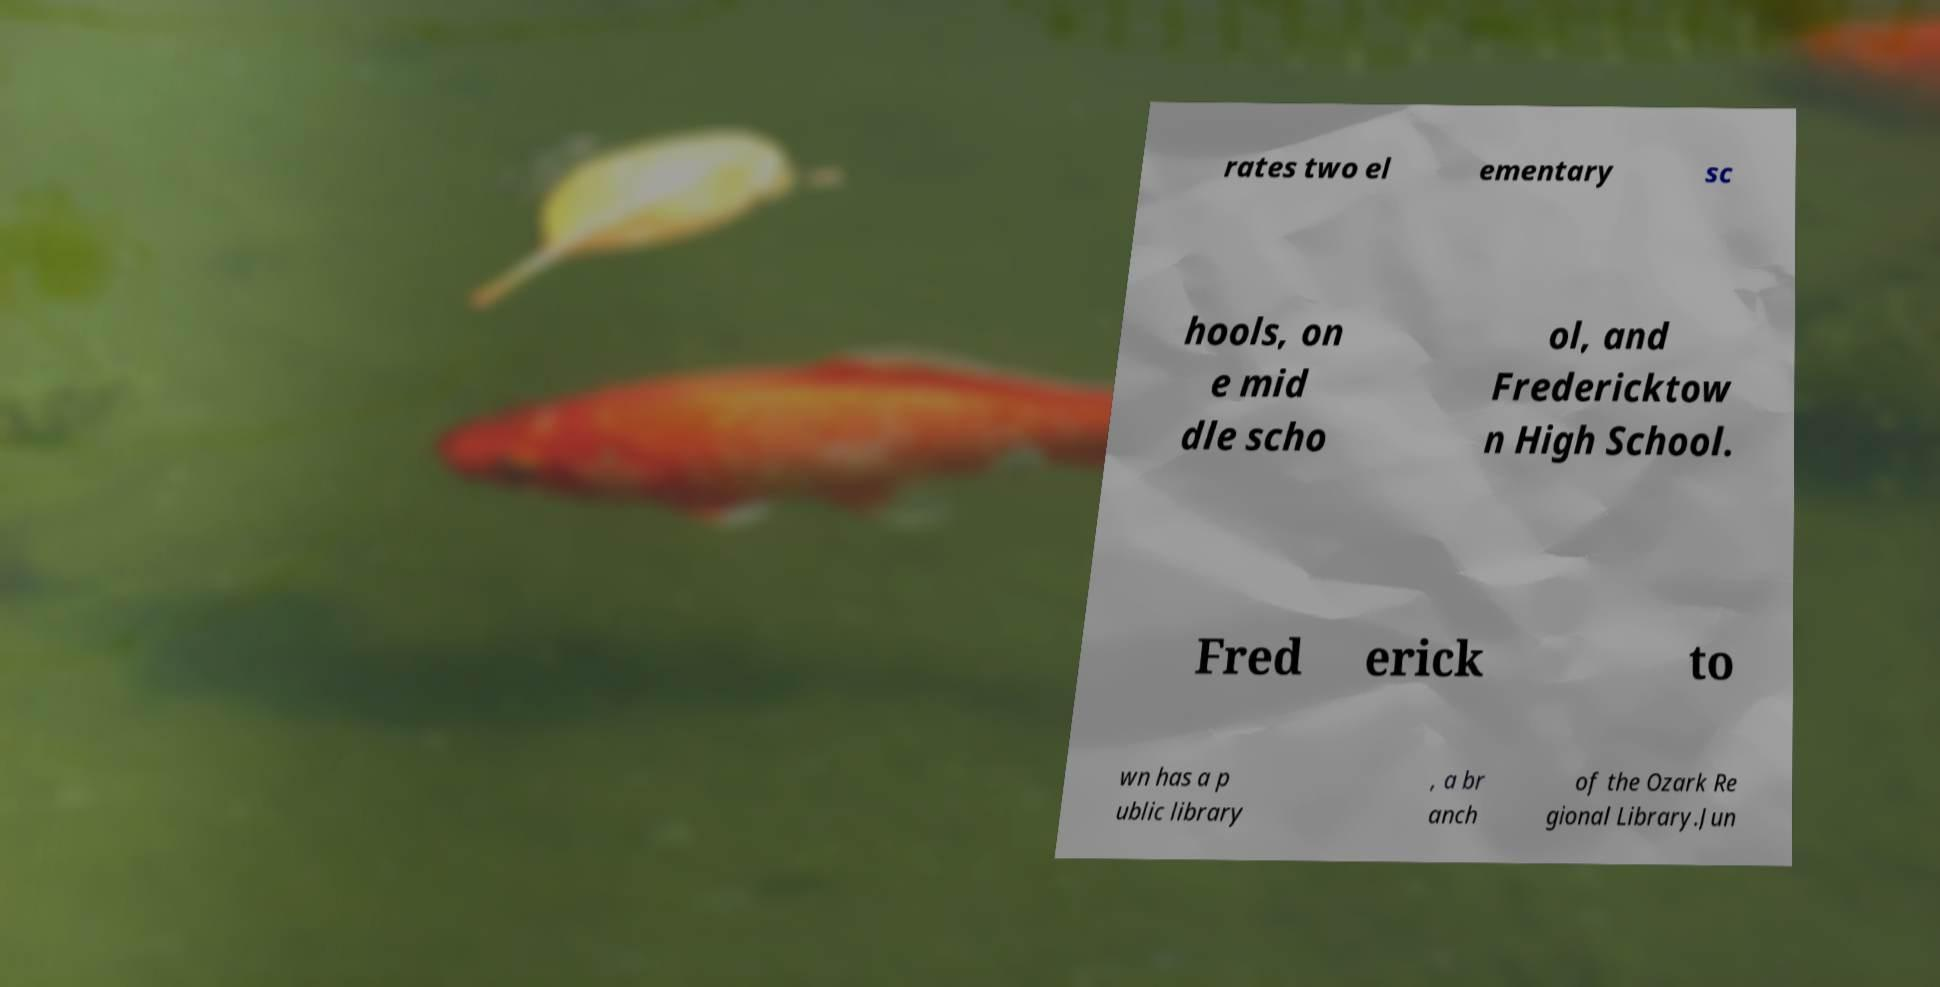Can you accurately transcribe the text from the provided image for me? rates two el ementary sc hools, on e mid dle scho ol, and Fredericktow n High School. Fred erick to wn has a p ublic library , a br anch of the Ozark Re gional Library.Jun 